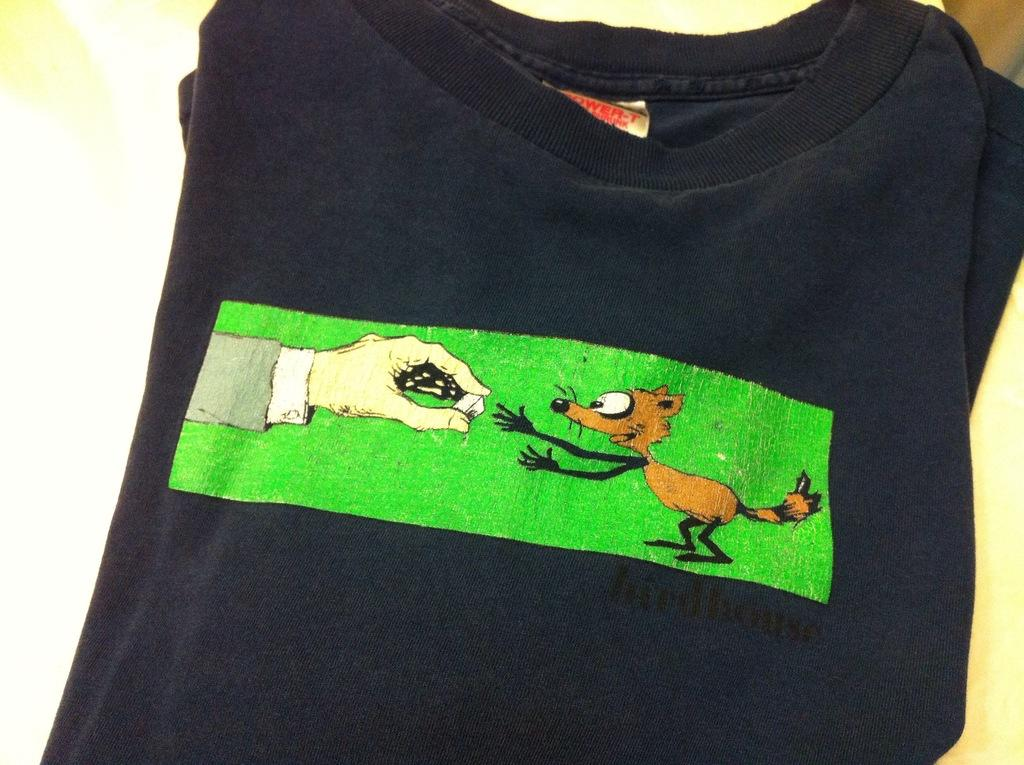What type of clothing item is in the image? There is a T-shirt in the image. What is featured on the T-shirt? There is print on the T-shirt. What message does the governor deliver to the crowd in the image? There is no governor or crowd present in the image; it only features a T-shirt with print on it. 